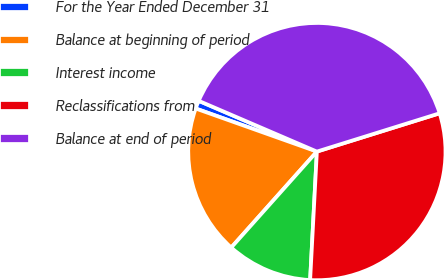Convert chart. <chart><loc_0><loc_0><loc_500><loc_500><pie_chart><fcel>For the Year Ended December 31<fcel>Balance at beginning of period<fcel>Interest income<fcel>Reclassifications from<fcel>Balance at end of period<nl><fcel>1.02%<fcel>18.84%<fcel>10.76%<fcel>30.65%<fcel>38.73%<nl></chart> 